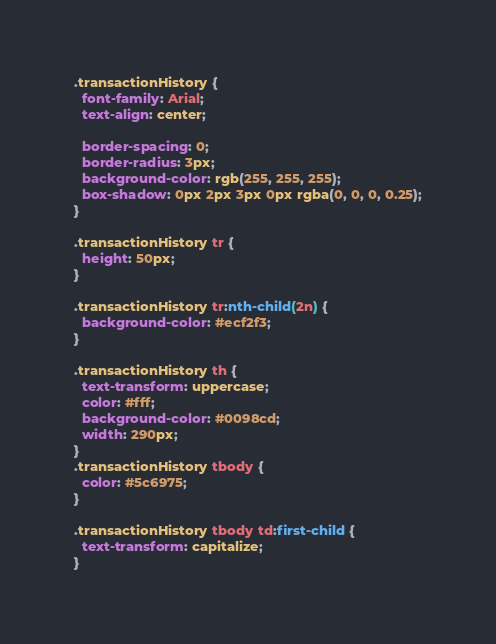Convert code to text. <code><loc_0><loc_0><loc_500><loc_500><_CSS_>.transactionHistory {
  font-family: Arial;
  text-align: center;

  border-spacing: 0;
  border-radius: 3px;
  background-color: rgb(255, 255, 255);
  box-shadow: 0px 2px 3px 0px rgba(0, 0, 0, 0.25);
}

.transactionHistory tr {
  height: 50px;
}

.transactionHistory tr:nth-child(2n) {
  background-color: #ecf2f3;
}

.transactionHistory th {
  text-transform: uppercase;
  color: #fff;
  background-color: #0098cd;
  width: 290px;
}
.transactionHistory tbody {
  color: #5c6975;
}

.transactionHistory tbody td:first-child {
  text-transform: capitalize;
}
</code> 